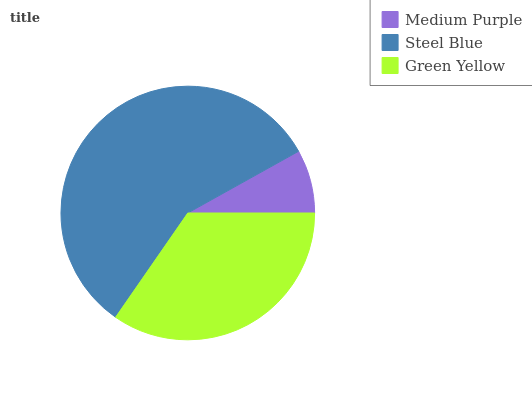Is Medium Purple the minimum?
Answer yes or no. Yes. Is Steel Blue the maximum?
Answer yes or no. Yes. Is Green Yellow the minimum?
Answer yes or no. No. Is Green Yellow the maximum?
Answer yes or no. No. Is Steel Blue greater than Green Yellow?
Answer yes or no. Yes. Is Green Yellow less than Steel Blue?
Answer yes or no. Yes. Is Green Yellow greater than Steel Blue?
Answer yes or no. No. Is Steel Blue less than Green Yellow?
Answer yes or no. No. Is Green Yellow the high median?
Answer yes or no. Yes. Is Green Yellow the low median?
Answer yes or no. Yes. Is Medium Purple the high median?
Answer yes or no. No. Is Medium Purple the low median?
Answer yes or no. No. 